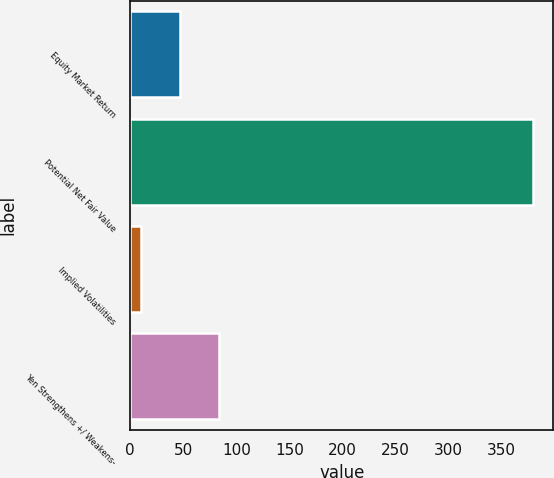Convert chart. <chart><loc_0><loc_0><loc_500><loc_500><bar_chart><fcel>Equity Market Return<fcel>Potential Net Fair Value<fcel>Implied Volatilities<fcel>Yen Strengthens +/ Weakens-<nl><fcel>47<fcel>380<fcel>10<fcel>84<nl></chart> 